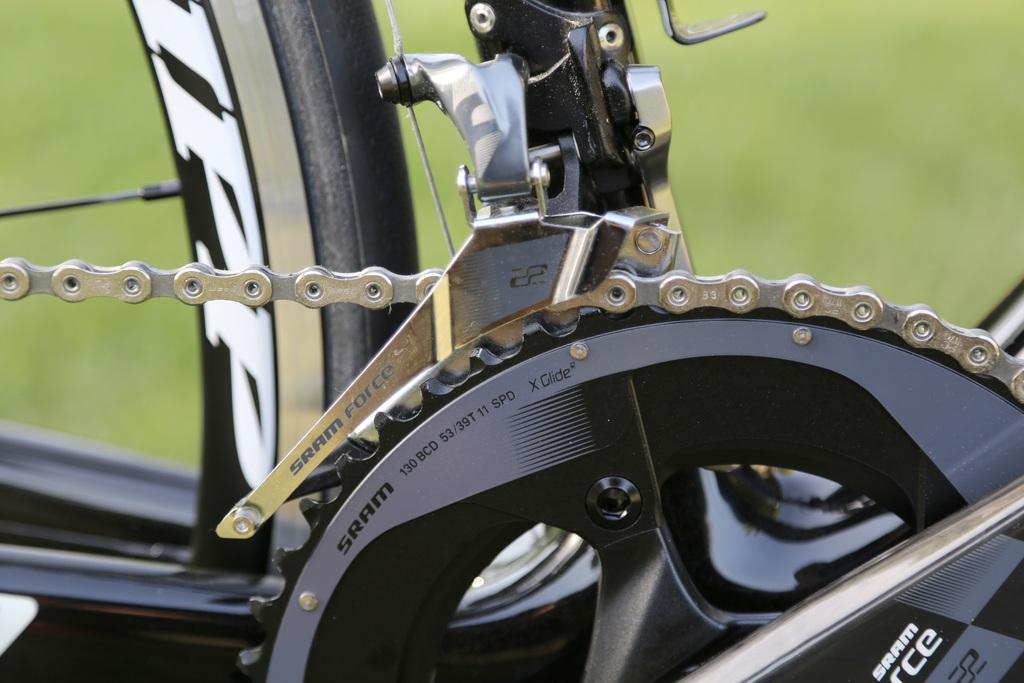What is the main object in the image? There is a bicycle in the image. What material is used for the chain on the bicycle? The bicycle has a metal chain. What part of the bicycle is made of metal? The bicycle has a metal wheel. Can you describe the background of the image? The background of the image is blurry. What type of hat is the secretary wearing in the image? There is no secretary or hat present in the image; it features a bicycle with a metal chain and wheel, and a blurry background. 